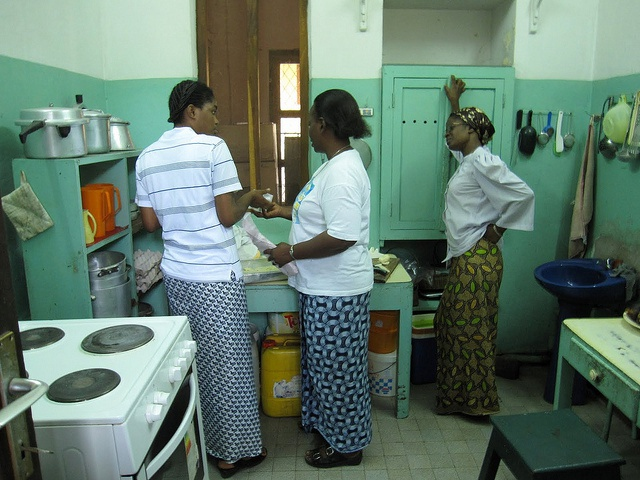Describe the objects in this image and their specific colors. I can see people in darkgray, black, lightblue, and teal tones, people in darkgray, lightblue, black, and gray tones, oven in darkgray, lightblue, gray, and black tones, people in darkgray, black, darkgreen, and gray tones, and chair in darkgray, black, darkgreen, and teal tones in this image. 